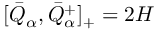Convert formula to latex. <formula><loc_0><loc_0><loc_500><loc_500>[ \bar { Q } _ { \alpha } , \bar { Q } _ { \alpha } ^ { + } ] _ { + } = 2 H</formula> 